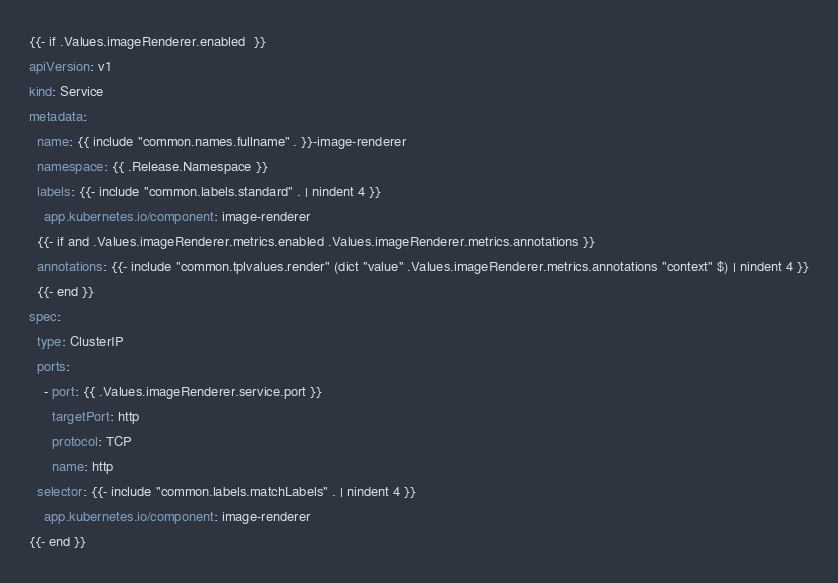<code> <loc_0><loc_0><loc_500><loc_500><_YAML_>{{- if .Values.imageRenderer.enabled  }}
apiVersion: v1
kind: Service
metadata:
  name: {{ include "common.names.fullname" . }}-image-renderer
  namespace: {{ .Release.Namespace }}
  labels: {{- include "common.labels.standard" . | nindent 4 }}
    app.kubernetes.io/component: image-renderer
  {{- if and .Values.imageRenderer.metrics.enabled .Values.imageRenderer.metrics.annotations }}
  annotations: {{- include "common.tplvalues.render" (dict "value" .Values.imageRenderer.metrics.annotations "context" $) | nindent 4 }}
  {{- end }}
spec:
  type: ClusterIP
  ports:
    - port: {{ .Values.imageRenderer.service.port }}
      targetPort: http
      protocol: TCP
      name: http
  selector: {{- include "common.labels.matchLabels" . | nindent 4 }}
    app.kubernetes.io/component: image-renderer
{{- end }}
</code> 